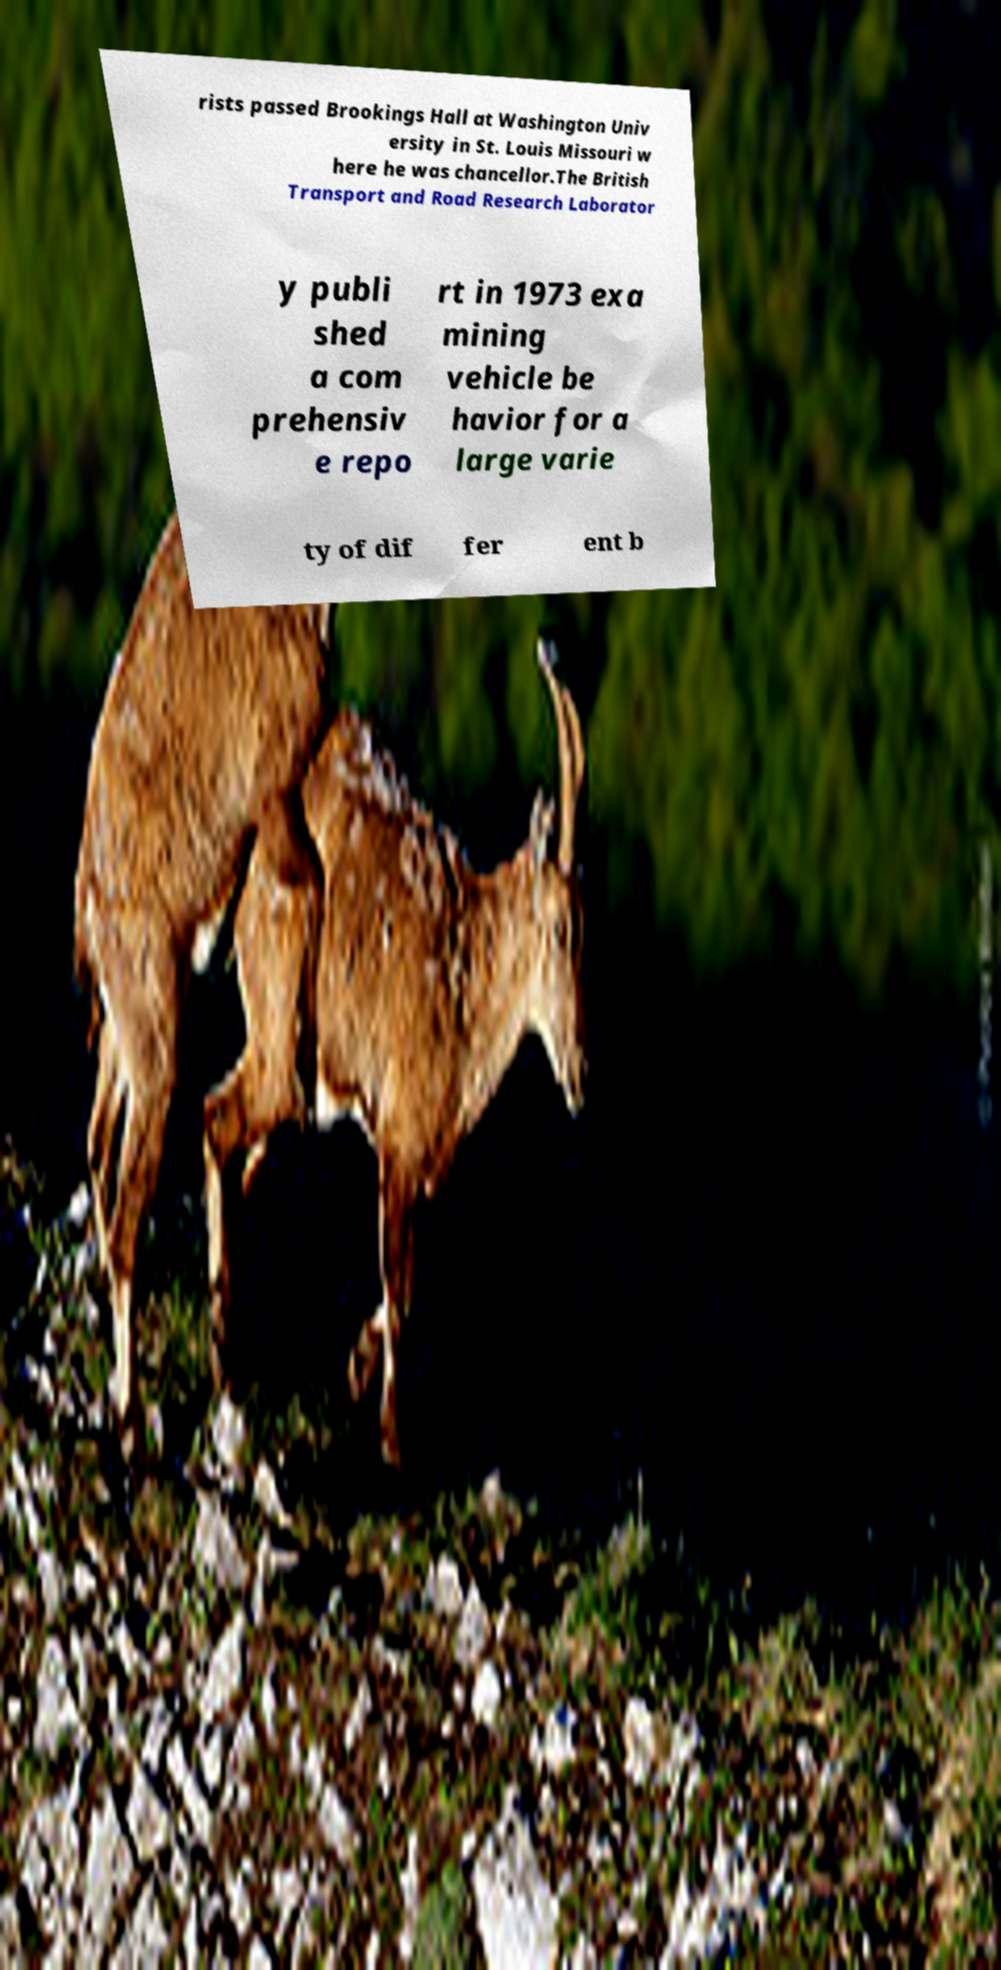Can you accurately transcribe the text from the provided image for me? rists passed Brookings Hall at Washington Univ ersity in St. Louis Missouri w here he was chancellor.The British Transport and Road Research Laborator y publi shed a com prehensiv e repo rt in 1973 exa mining vehicle be havior for a large varie ty of dif fer ent b 